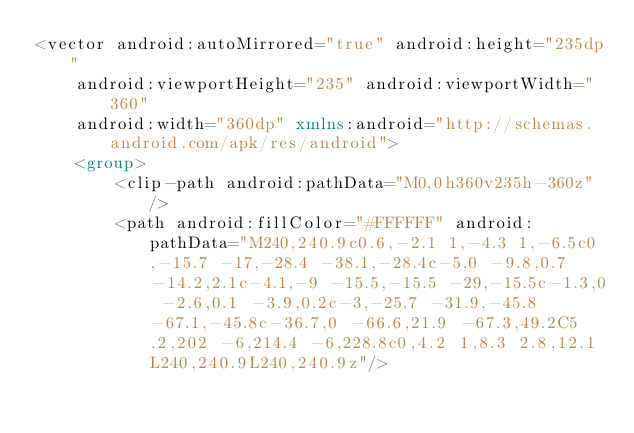Convert code to text. <code><loc_0><loc_0><loc_500><loc_500><_XML_><vector android:autoMirrored="true" android:height="235dp"
    android:viewportHeight="235" android:viewportWidth="360"
    android:width="360dp" xmlns:android="http://schemas.android.com/apk/res/android">
    <group>
        <clip-path android:pathData="M0,0h360v235h-360z"/>
        <path android:fillColor="#FFFFFF" android:pathData="M240,240.9c0.6,-2.1 1,-4.3 1,-6.5c0,-15.7 -17,-28.4 -38.1,-28.4c-5,0 -9.8,0.7 -14.2,2.1c-4.1,-9 -15.5,-15.5 -29,-15.5c-1.3,0 -2.6,0.1 -3.9,0.2c-3,-25.7 -31.9,-45.8 -67.1,-45.8c-36.7,0 -66.6,21.9 -67.3,49.2C5.2,202 -6,214.4 -6,228.8c0,4.2 1,8.3 2.8,12.1L240,240.9L240,240.9z"/></code> 